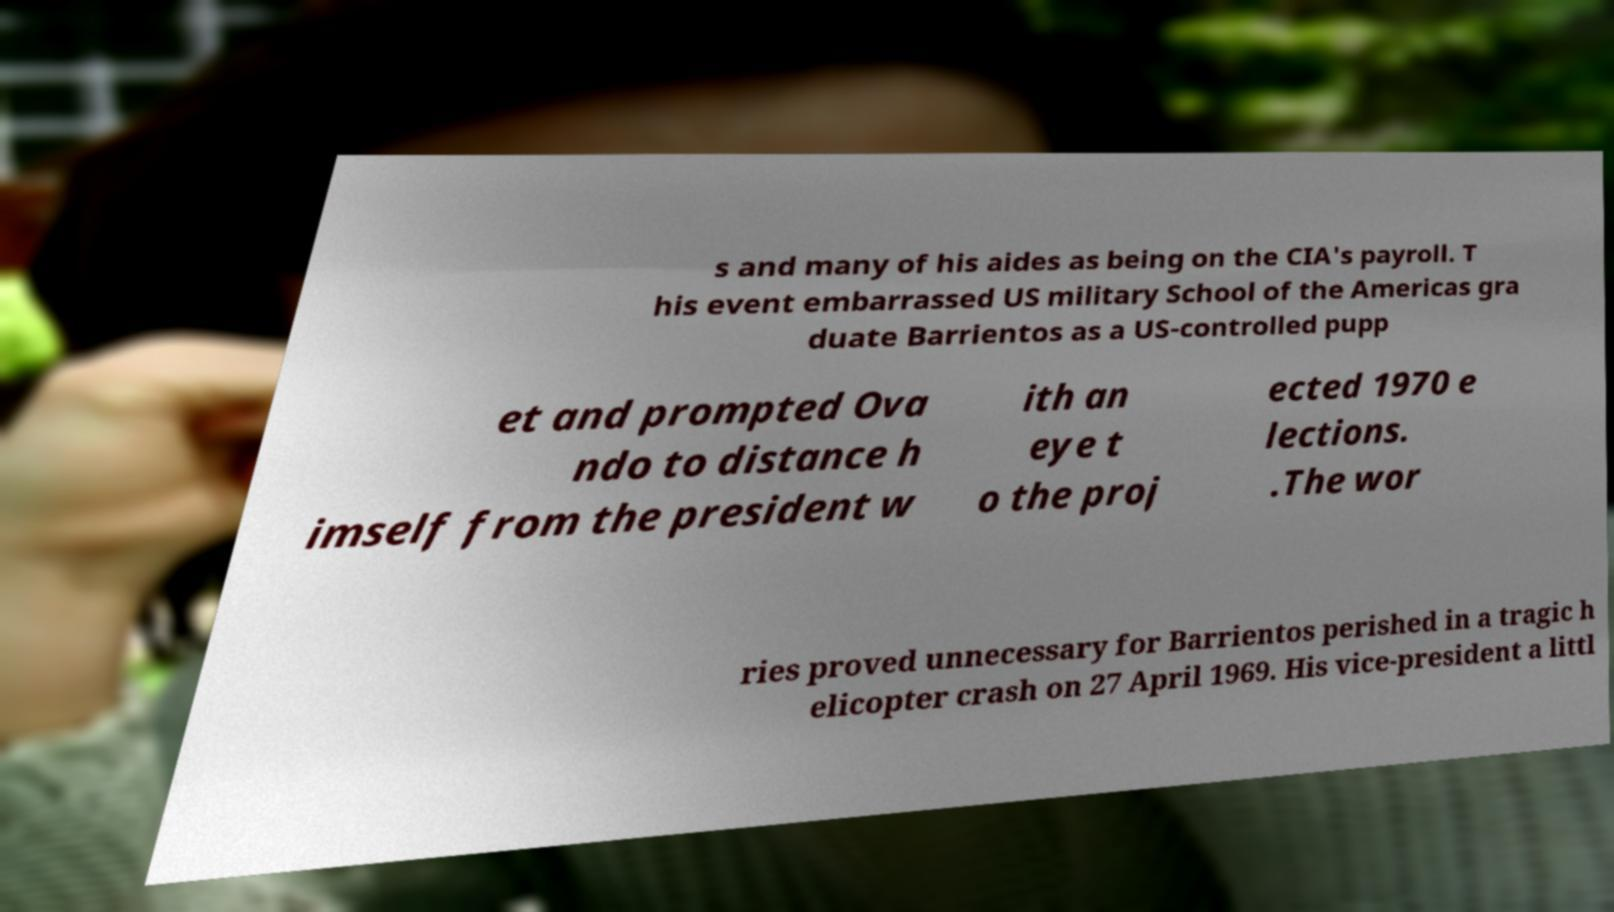Could you extract and type out the text from this image? s and many of his aides as being on the CIA's payroll. T his event embarrassed US military School of the Americas gra duate Barrientos as a US-controlled pupp et and prompted Ova ndo to distance h imself from the president w ith an eye t o the proj ected 1970 e lections. .The wor ries proved unnecessary for Barrientos perished in a tragic h elicopter crash on 27 April 1969. His vice-president a littl 